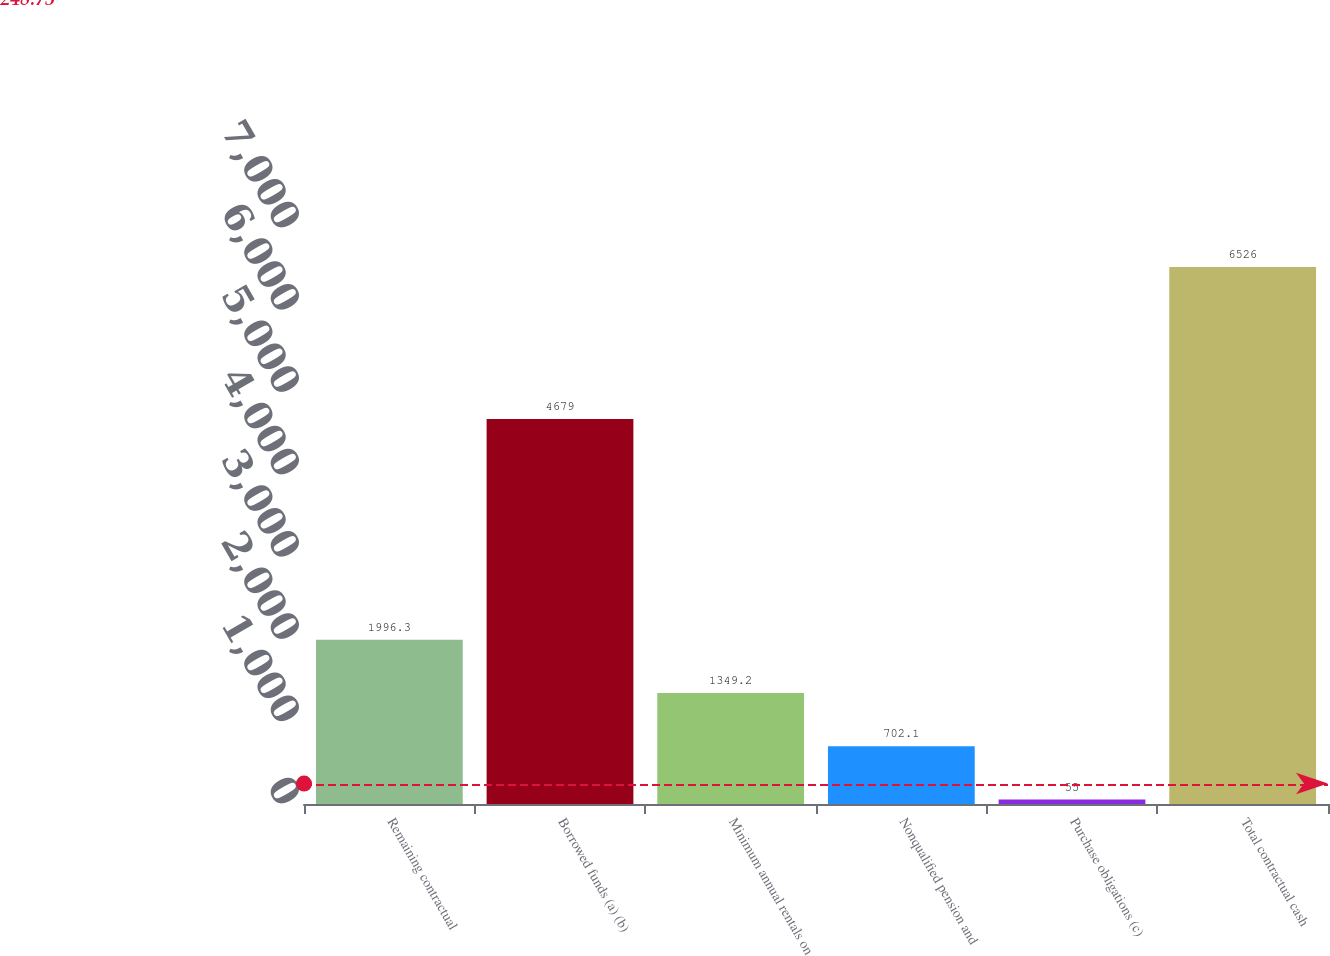<chart> <loc_0><loc_0><loc_500><loc_500><bar_chart><fcel>Remaining contractual<fcel>Borrowed funds (a) (b)<fcel>Minimum annual rentals on<fcel>Nonqualified pension and<fcel>Purchase obligations (c)<fcel>Total contractual cash<nl><fcel>1996.3<fcel>4679<fcel>1349.2<fcel>702.1<fcel>55<fcel>6526<nl></chart> 